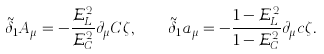Convert formula to latex. <formula><loc_0><loc_0><loc_500><loc_500>\tilde { \delta } _ { 1 } A _ { \mu } = - \frac { \mathcal { E } _ { L } ^ { 2 } } { \mathcal { E } _ { C } ^ { 2 } } \partial _ { \mu } C \zeta , \quad \tilde { \delta } _ { 1 } a _ { \mu } = - \frac { 1 - \mathcal { E } _ { L } ^ { 2 } } { 1 - \mathcal { E } _ { C } ^ { 2 } } \partial _ { \mu } c \zeta .</formula> 